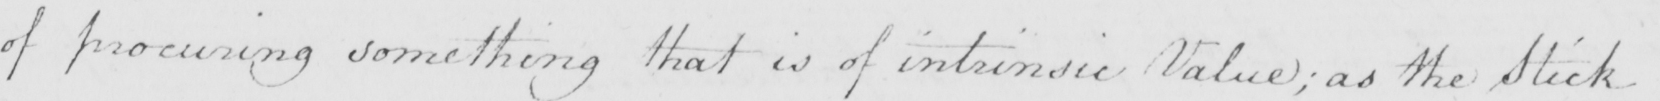Can you tell me what this handwritten text says? of procuring something that is of intrinsic Value ; as the Stick 